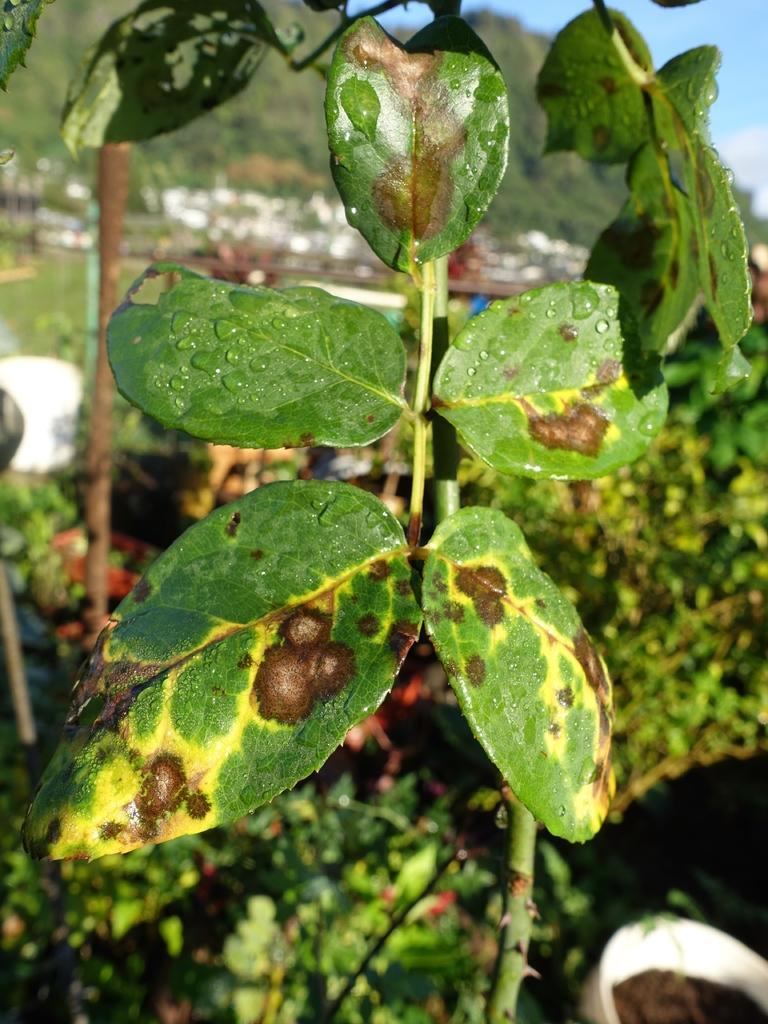What type of vegetation is present in the image? There are leaves with yellow and brown colors in the image. What might be the cause of the yellow and brown colors on the leaves? The affected area is visible, which suggests that the leaves may be experiencing discoloration due to a change in season or a disease. What is visible at the top of the image? The sky is visible at the top of the image. What type of songs can be heard playing in the library in the image? There is no library or songs present in the image; it features leaves with yellow and brown colors and a visible sky. 